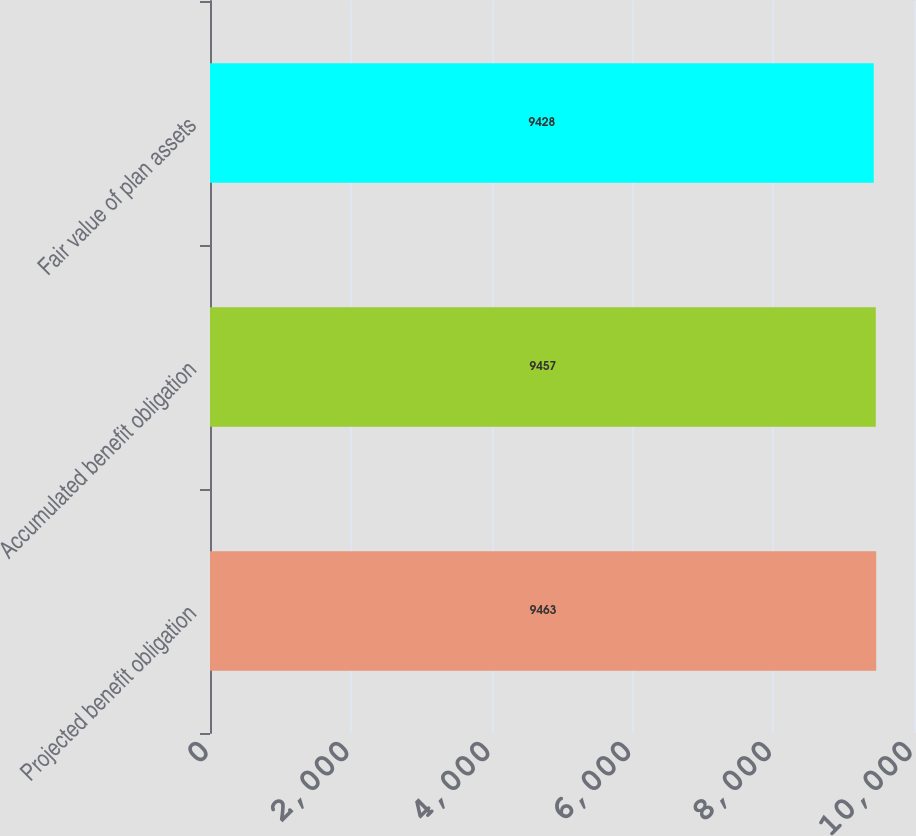Convert chart. <chart><loc_0><loc_0><loc_500><loc_500><bar_chart><fcel>Projected benefit obligation<fcel>Accumulated benefit obligation<fcel>Fair value of plan assets<nl><fcel>9463<fcel>9457<fcel>9428<nl></chart> 